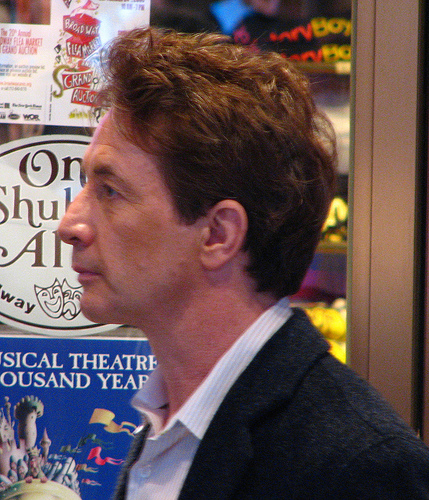<image>
Is there a man next to the sign? No. The man is not positioned next to the sign. They are located in different areas of the scene. 